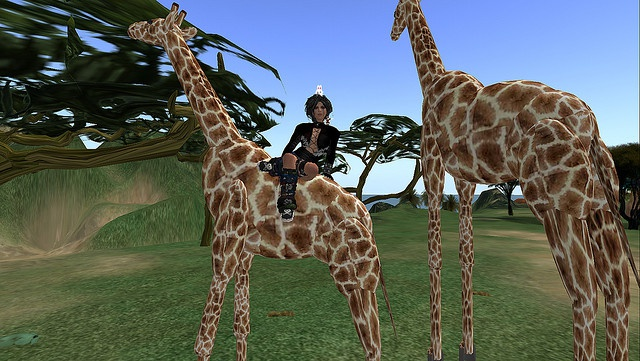Describe the objects in this image and their specific colors. I can see giraffe in black, maroon, and gray tones, giraffe in black, maroon, gray, and darkgray tones, and people in black, gray, and maroon tones in this image. 